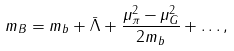Convert formula to latex. <formula><loc_0><loc_0><loc_500><loc_500>m _ { B } = m _ { b } + \bar { \Lambda } + \frac { \mu _ { \pi } ^ { 2 } - \mu _ { G } ^ { 2 } } { 2 m _ { b } } + \dots ,</formula> 